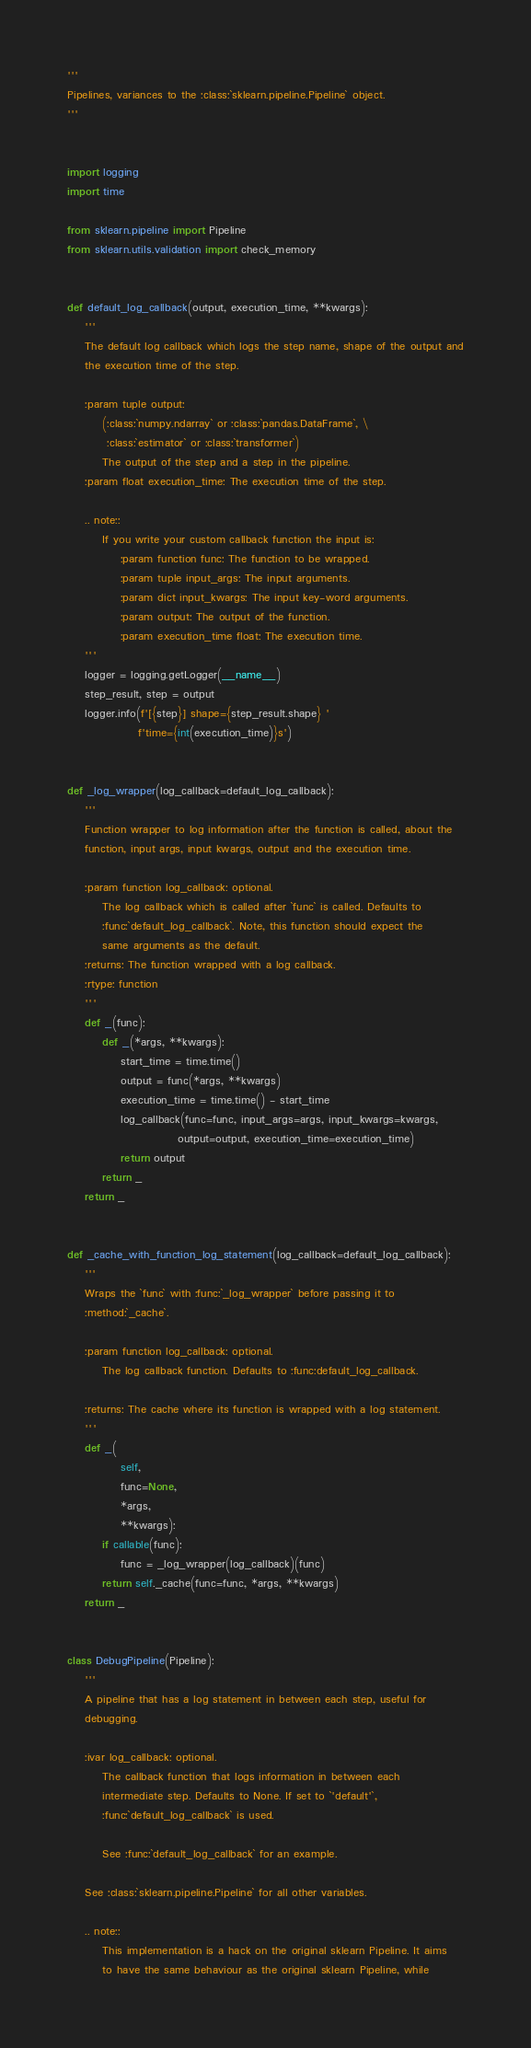<code> <loc_0><loc_0><loc_500><loc_500><_Python_>'''
Pipelines, variances to the :class:`sklearn.pipeline.Pipeline` object.
'''


import logging
import time

from sklearn.pipeline import Pipeline
from sklearn.utils.validation import check_memory


def default_log_callback(output, execution_time, **kwargs):
    '''
    The default log callback which logs the step name, shape of the output and
    the execution time of the step.

    :param tuple output:
        (:class:`numpy.ndarray` or :class:`pandas.DataFrame`, \
         :class:`estimator` or :class:`transformer`)
        The output of the step and a step in the pipeline.
    :param float execution_time: The execution time of the step.

    .. note::
        If you write your custom callback function the input is:
            :param function func: The function to be wrapped.
            :param tuple input_args: The input arguments.
            :param dict input_kwargs: The input key-word arguments.
            :param output: The output of the function.
            :param execution_time float: The execution time.
    '''
    logger = logging.getLogger(__name__)
    step_result, step = output
    logger.info(f'[{step}] shape={step_result.shape} '
                f'time={int(execution_time)}s')


def _log_wrapper(log_callback=default_log_callback):
    '''
    Function wrapper to log information after the function is called, about the
    function, input args, input kwargs, output and the execution time.

    :param function log_callback: optional.
        The log callback which is called after `func` is called. Defaults to
        :func:`default_log_callback`. Note, this function should expect the
        same arguments as the default.
    :returns: The function wrapped with a log callback.
    :rtype: function
    '''
    def _(func):
        def _(*args, **kwargs):
            start_time = time.time()
            output = func(*args, **kwargs)
            execution_time = time.time() - start_time
            log_callback(func=func, input_args=args, input_kwargs=kwargs,
                         output=output, execution_time=execution_time)
            return output
        return _
    return _


def _cache_with_function_log_statement(log_callback=default_log_callback):
    '''
    Wraps the `func` with :func:`_log_wrapper` before passing it to
    :method:`_cache`.

    :param function log_callback: optional.
        The log callback function. Defaults to :func:default_log_callback.

    :returns: The cache where its function is wrapped with a log statement.
    '''
    def _(
            self,
            func=None,
            *args,
            **kwargs):
        if callable(func):
            func = _log_wrapper(log_callback)(func)
        return self._cache(func=func, *args, **kwargs)
    return _


class DebugPipeline(Pipeline):
    '''
    A pipeline that has a log statement in between each step, useful for
    debugging.

    :ivar log_callback: optional.
        The callback function that logs information in between each
        intermediate step. Defaults to None. If set to `'default'`,
        :func:`default_log_callback` is used.

        See :func:`default_log_callback` for an example.

    See :class:`sklearn.pipeline.Pipeline` for all other variables.

    .. note::
        This implementation is a hack on the original sklearn Pipeline. It aims
        to have the same behaviour as the original sklearn Pipeline, while</code> 